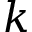<formula> <loc_0><loc_0><loc_500><loc_500>k</formula> 